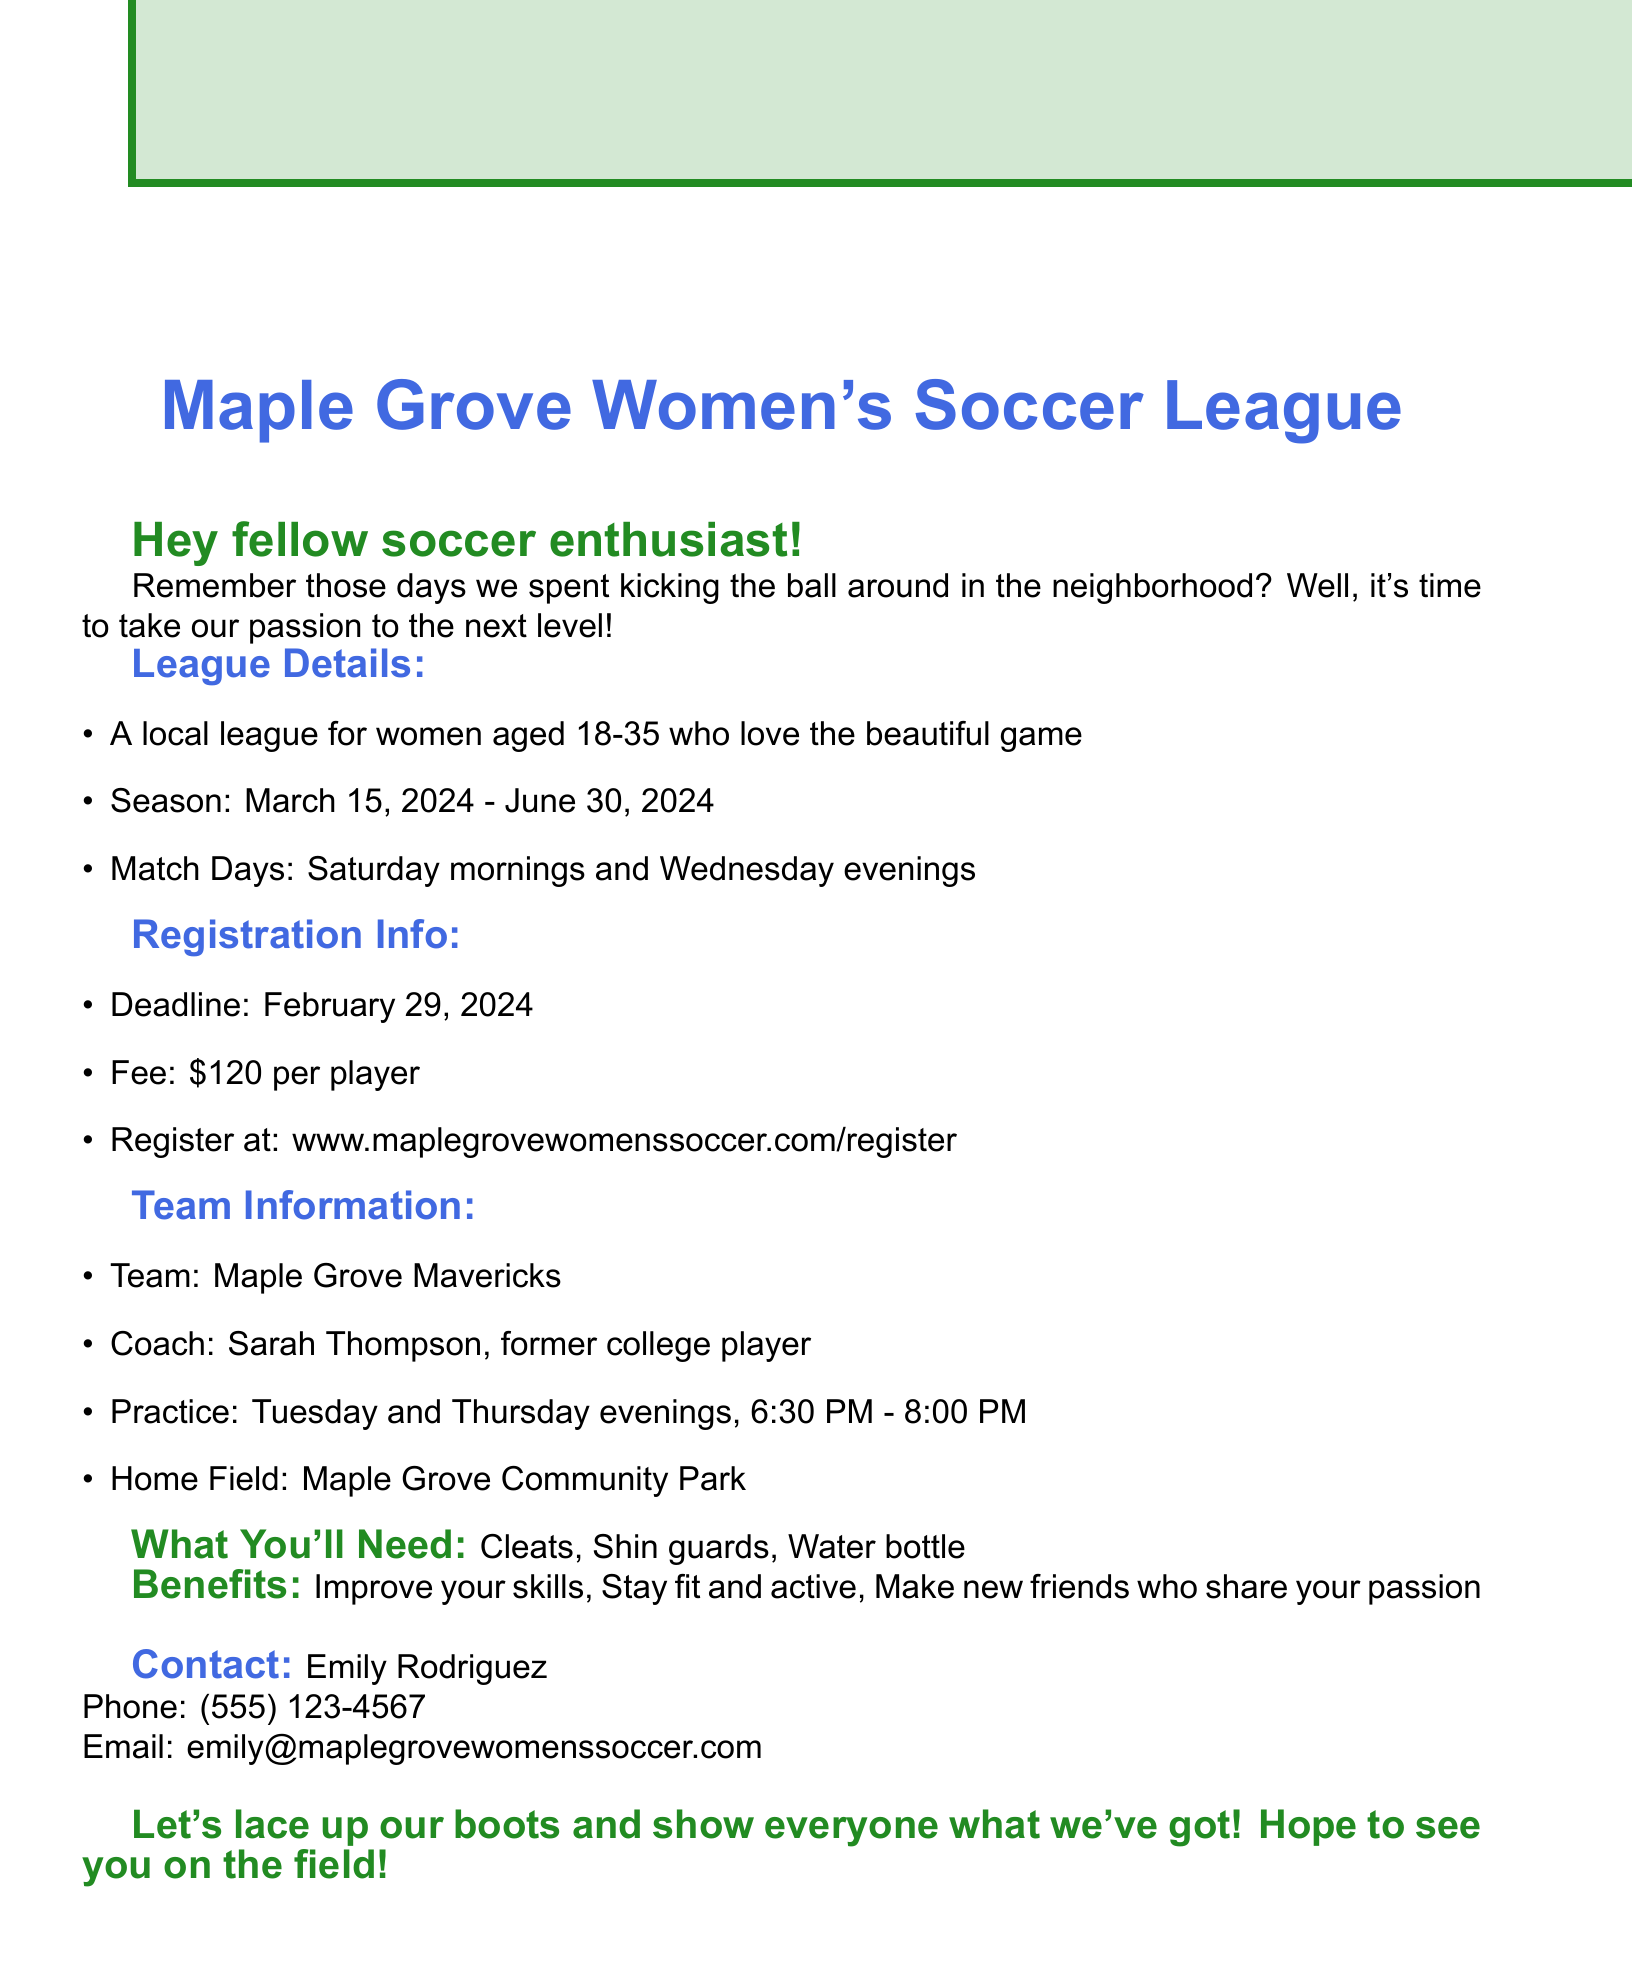what is the league name? The league name is mentioned in the document as Maple Grove Women's Soccer League.
Answer: Maple Grove Women's Soccer League what is the registration deadline? The registration deadline is clearly stated in the document.
Answer: February 29, 2024 who is the coach of the team? The name of the coach is provided in the team information section.
Answer: Sarah Thompson what is the practice schedule? The practice schedule is listed in the team information section of the document.
Answer: Tuesday and Thursday evenings, 6:30 PM - 8:00 PM what is the registration fee per player? The fee is specified in the registration info, showing the cost to join the league.
Answer: $120 per player what are the match days? Match days are mentioned in the league details, providing information on when the games are held.
Answer: Saturday mornings and Wednesday evenings how long is the season? The season details provide the starting and ending dates for the league season.
Answer: March 15, 2024 - June 30, 2024 what equipment is needed to play? The document lists the necessary equipment for players in the section titled "What You'll Need."
Answer: Cleats, Shin guards, Water bottle who should I contact for more information? The contact person is mentioned at the end of the document along with their details.
Answer: Emily Rodriguez 